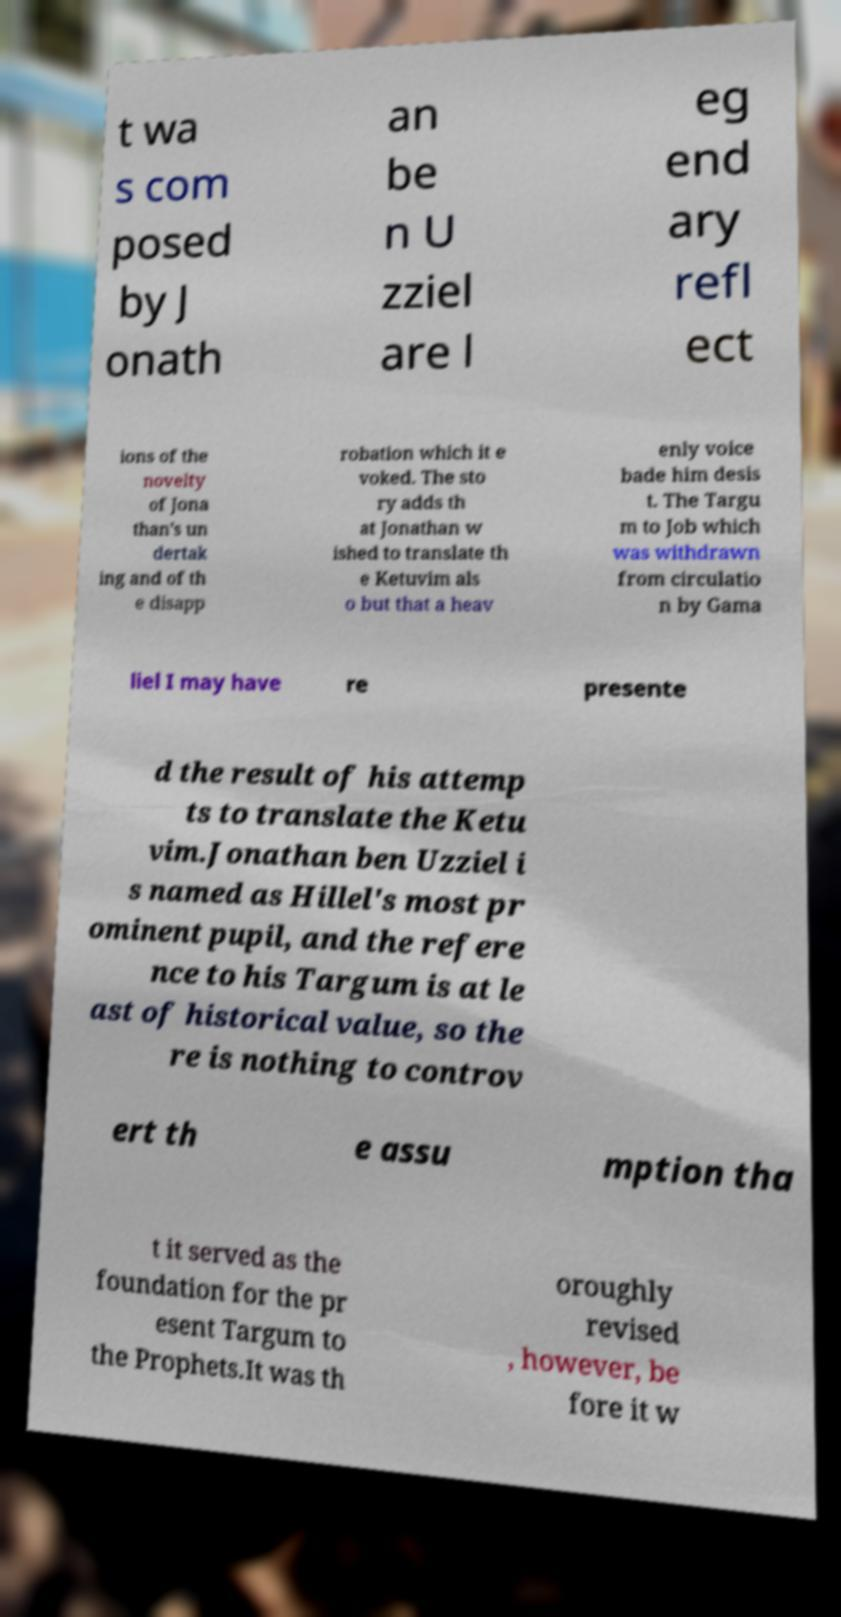For documentation purposes, I need the text within this image transcribed. Could you provide that? t wa s com posed by J onath an be n U zziel are l eg end ary refl ect ions of the novelty of Jona than's un dertak ing and of th e disapp robation which it e voked. The sto ry adds th at Jonathan w ished to translate th e Ketuvim als o but that a heav enly voice bade him desis t. The Targu m to Job which was withdrawn from circulatio n by Gama liel I may have re presente d the result of his attemp ts to translate the Ketu vim.Jonathan ben Uzziel i s named as Hillel's most pr ominent pupil, and the refere nce to his Targum is at le ast of historical value, so the re is nothing to controv ert th e assu mption tha t it served as the foundation for the pr esent Targum to the Prophets.It was th oroughly revised , however, be fore it w 